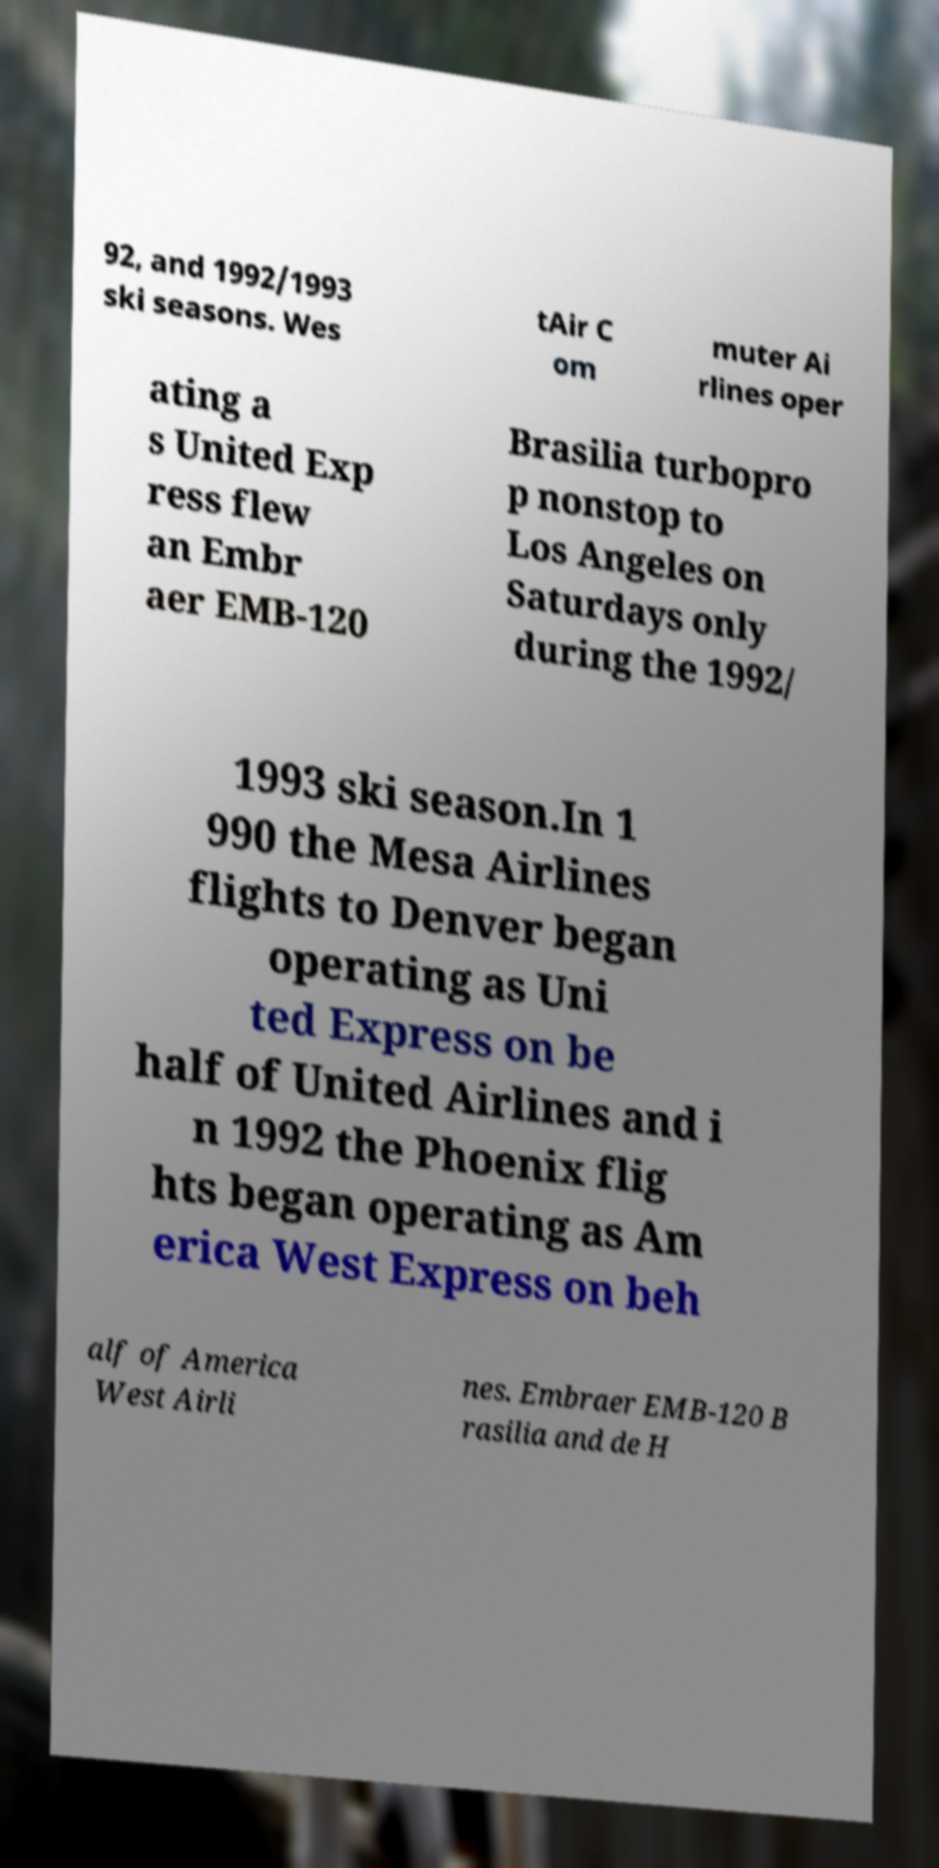Could you extract and type out the text from this image? 92, and 1992/1993 ski seasons. Wes tAir C om muter Ai rlines oper ating a s United Exp ress flew an Embr aer EMB-120 Brasilia turbopro p nonstop to Los Angeles on Saturdays only during the 1992/ 1993 ski season.In 1 990 the Mesa Airlines flights to Denver began operating as Uni ted Express on be half of United Airlines and i n 1992 the Phoenix flig hts began operating as Am erica West Express on beh alf of America West Airli nes. Embraer EMB-120 B rasilia and de H 